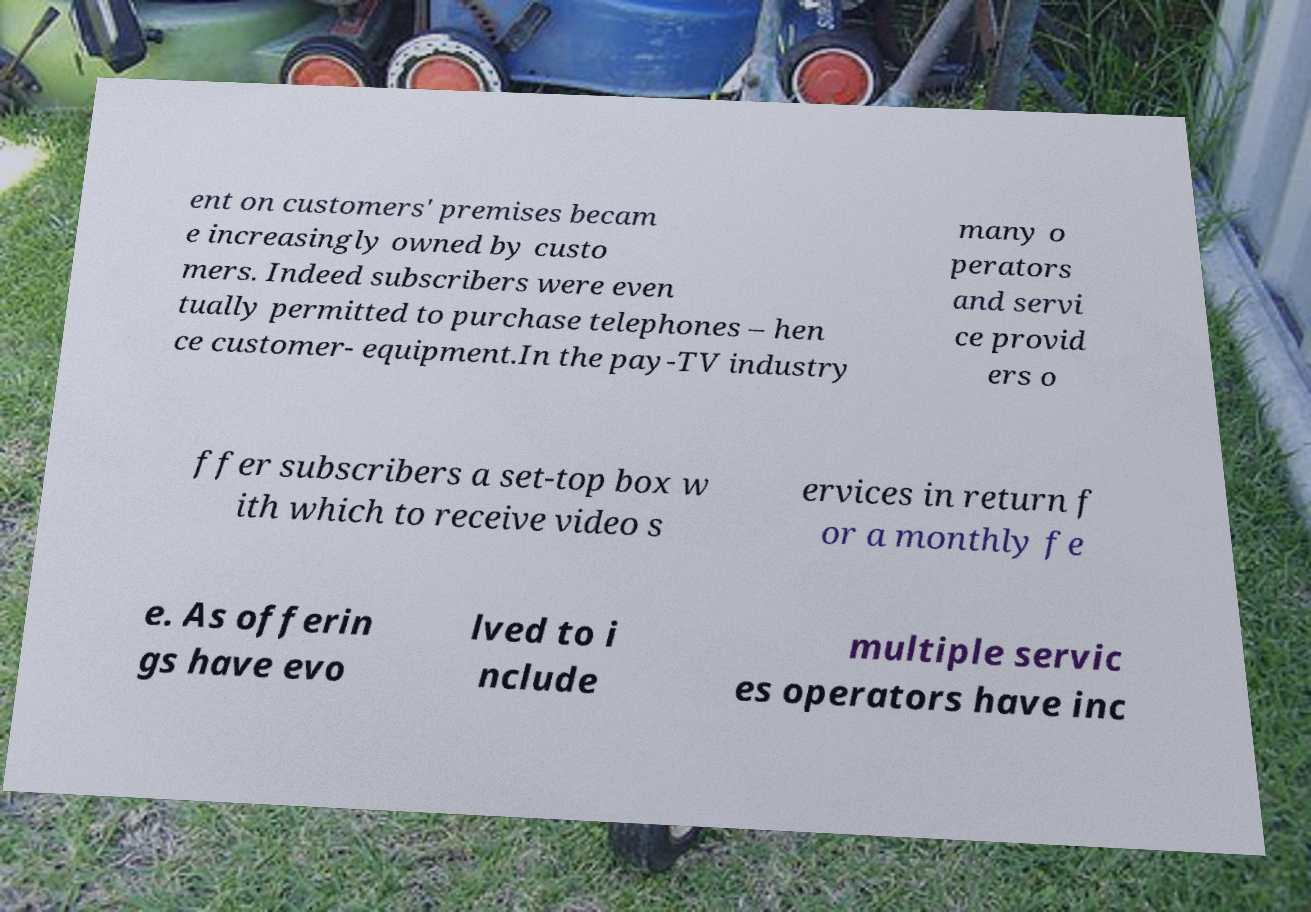What messages or text are displayed in this image? I need them in a readable, typed format. ent on customers' premises becam e increasingly owned by custo mers. Indeed subscribers were even tually permitted to purchase telephones – hen ce customer- equipment.In the pay-TV industry many o perators and servi ce provid ers o ffer subscribers a set-top box w ith which to receive video s ervices in return f or a monthly fe e. As offerin gs have evo lved to i nclude multiple servic es operators have inc 